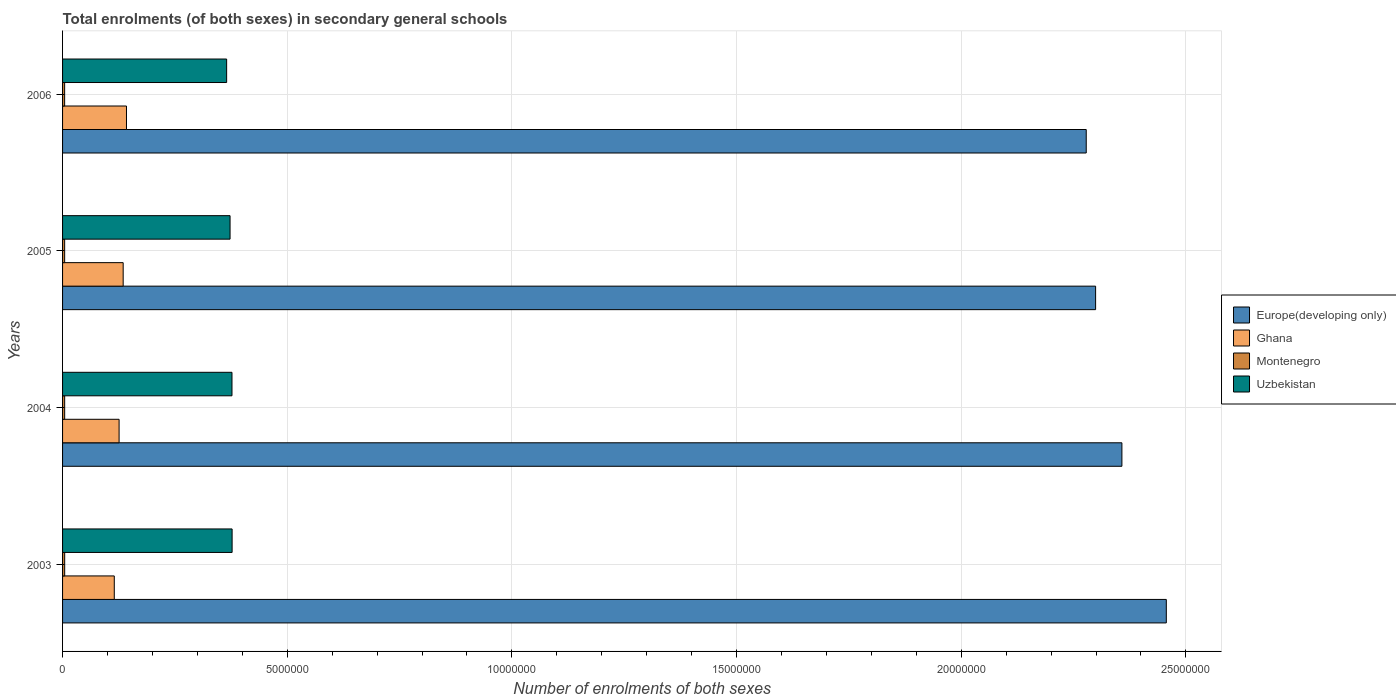How many different coloured bars are there?
Your response must be concise. 4. How many groups of bars are there?
Offer a terse response. 4. Are the number of bars per tick equal to the number of legend labels?
Your answer should be very brief. Yes. Are the number of bars on each tick of the Y-axis equal?
Make the answer very short. Yes. How many bars are there on the 2nd tick from the top?
Offer a terse response. 4. What is the number of enrolments in secondary schools in Uzbekistan in 2005?
Make the answer very short. 3.73e+06. Across all years, what is the maximum number of enrolments in secondary schools in Europe(developing only)?
Your answer should be very brief. 2.46e+07. Across all years, what is the minimum number of enrolments in secondary schools in Uzbekistan?
Your answer should be compact. 3.65e+06. In which year was the number of enrolments in secondary schools in Montenegro maximum?
Provide a short and direct response. 2003. In which year was the number of enrolments in secondary schools in Europe(developing only) minimum?
Offer a very short reply. 2006. What is the total number of enrolments in secondary schools in Uzbekistan in the graph?
Your answer should be very brief. 1.49e+07. What is the difference between the number of enrolments in secondary schools in Ghana in 2004 and that in 2005?
Provide a succinct answer. -9.08e+04. What is the difference between the number of enrolments in secondary schools in Ghana in 2004 and the number of enrolments in secondary schools in Europe(developing only) in 2003?
Provide a succinct answer. -2.33e+07. What is the average number of enrolments in secondary schools in Europe(developing only) per year?
Ensure brevity in your answer.  2.35e+07. In the year 2005, what is the difference between the number of enrolments in secondary schools in Ghana and number of enrolments in secondary schools in Montenegro?
Offer a terse response. 1.30e+06. In how many years, is the number of enrolments in secondary schools in Montenegro greater than 13000000 ?
Ensure brevity in your answer.  0. What is the ratio of the number of enrolments in secondary schools in Montenegro in 2004 to that in 2005?
Your answer should be compact. 1.01. Is the number of enrolments in secondary schools in Ghana in 2003 less than that in 2004?
Your response must be concise. Yes. Is the difference between the number of enrolments in secondary schools in Ghana in 2003 and 2006 greater than the difference between the number of enrolments in secondary schools in Montenegro in 2003 and 2006?
Make the answer very short. No. What is the difference between the highest and the second highest number of enrolments in secondary schools in Ghana?
Your response must be concise. 7.38e+04. What is the difference between the highest and the lowest number of enrolments in secondary schools in Uzbekistan?
Give a very brief answer. 1.22e+05. In how many years, is the number of enrolments in secondary schools in Montenegro greater than the average number of enrolments in secondary schools in Montenegro taken over all years?
Offer a very short reply. 2. Is the sum of the number of enrolments in secondary schools in Europe(developing only) in 2003 and 2004 greater than the maximum number of enrolments in secondary schools in Uzbekistan across all years?
Provide a succinct answer. Yes. Is it the case that in every year, the sum of the number of enrolments in secondary schools in Europe(developing only) and number of enrolments in secondary schools in Ghana is greater than the sum of number of enrolments in secondary schools in Montenegro and number of enrolments in secondary schools in Uzbekistan?
Your answer should be very brief. Yes. What does the 2nd bar from the top in 2004 represents?
Your answer should be compact. Montenegro. What does the 1st bar from the bottom in 2003 represents?
Make the answer very short. Europe(developing only). Is it the case that in every year, the sum of the number of enrolments in secondary schools in Montenegro and number of enrolments in secondary schools in Uzbekistan is greater than the number of enrolments in secondary schools in Europe(developing only)?
Offer a very short reply. No. How many bars are there?
Your answer should be compact. 16. What is the difference between two consecutive major ticks on the X-axis?
Provide a short and direct response. 5.00e+06. Are the values on the major ticks of X-axis written in scientific E-notation?
Your response must be concise. No. How are the legend labels stacked?
Ensure brevity in your answer.  Vertical. What is the title of the graph?
Make the answer very short. Total enrolments (of both sexes) in secondary general schools. What is the label or title of the X-axis?
Keep it short and to the point. Number of enrolments of both sexes. What is the label or title of the Y-axis?
Your response must be concise. Years. What is the Number of enrolments of both sexes in Europe(developing only) in 2003?
Your answer should be compact. 2.46e+07. What is the Number of enrolments of both sexes of Ghana in 2003?
Your answer should be very brief. 1.15e+06. What is the Number of enrolments of both sexes in Montenegro in 2003?
Offer a very short reply. 4.72e+04. What is the Number of enrolments of both sexes of Uzbekistan in 2003?
Your answer should be compact. 3.77e+06. What is the Number of enrolments of both sexes of Europe(developing only) in 2004?
Provide a succinct answer. 2.36e+07. What is the Number of enrolments of both sexes in Ghana in 2004?
Your answer should be very brief. 1.26e+06. What is the Number of enrolments of both sexes in Montenegro in 2004?
Your response must be concise. 4.69e+04. What is the Number of enrolments of both sexes in Uzbekistan in 2004?
Offer a terse response. 3.77e+06. What is the Number of enrolments of both sexes in Europe(developing only) in 2005?
Offer a very short reply. 2.30e+07. What is the Number of enrolments of both sexes in Ghana in 2005?
Your response must be concise. 1.35e+06. What is the Number of enrolments of both sexes of Montenegro in 2005?
Keep it short and to the point. 4.65e+04. What is the Number of enrolments of both sexes in Uzbekistan in 2005?
Keep it short and to the point. 3.73e+06. What is the Number of enrolments of both sexes in Europe(developing only) in 2006?
Provide a succinct answer. 2.28e+07. What is the Number of enrolments of both sexes of Ghana in 2006?
Ensure brevity in your answer.  1.42e+06. What is the Number of enrolments of both sexes in Montenegro in 2006?
Your answer should be very brief. 4.62e+04. What is the Number of enrolments of both sexes in Uzbekistan in 2006?
Keep it short and to the point. 3.65e+06. Across all years, what is the maximum Number of enrolments of both sexes of Europe(developing only)?
Your response must be concise. 2.46e+07. Across all years, what is the maximum Number of enrolments of both sexes in Ghana?
Offer a terse response. 1.42e+06. Across all years, what is the maximum Number of enrolments of both sexes in Montenegro?
Offer a very short reply. 4.72e+04. Across all years, what is the maximum Number of enrolments of both sexes in Uzbekistan?
Give a very brief answer. 3.77e+06. Across all years, what is the minimum Number of enrolments of both sexes of Europe(developing only)?
Your response must be concise. 2.28e+07. Across all years, what is the minimum Number of enrolments of both sexes of Ghana?
Give a very brief answer. 1.15e+06. Across all years, what is the minimum Number of enrolments of both sexes in Montenegro?
Offer a terse response. 4.62e+04. Across all years, what is the minimum Number of enrolments of both sexes in Uzbekistan?
Make the answer very short. 3.65e+06. What is the total Number of enrolments of both sexes of Europe(developing only) in the graph?
Your response must be concise. 9.39e+07. What is the total Number of enrolments of both sexes of Ghana in the graph?
Give a very brief answer. 5.18e+06. What is the total Number of enrolments of both sexes of Montenegro in the graph?
Your response must be concise. 1.87e+05. What is the total Number of enrolments of both sexes of Uzbekistan in the graph?
Give a very brief answer. 1.49e+07. What is the difference between the Number of enrolments of both sexes in Europe(developing only) in 2003 and that in 2004?
Ensure brevity in your answer.  9.88e+05. What is the difference between the Number of enrolments of both sexes of Ghana in 2003 and that in 2004?
Make the answer very short. -1.07e+05. What is the difference between the Number of enrolments of both sexes of Montenegro in 2003 and that in 2004?
Provide a succinct answer. 286. What is the difference between the Number of enrolments of both sexes of Uzbekistan in 2003 and that in 2004?
Your answer should be very brief. 2988. What is the difference between the Number of enrolments of both sexes of Europe(developing only) in 2003 and that in 2005?
Provide a short and direct response. 1.57e+06. What is the difference between the Number of enrolments of both sexes of Ghana in 2003 and that in 2005?
Your answer should be compact. -1.98e+05. What is the difference between the Number of enrolments of both sexes of Montenegro in 2003 and that in 2005?
Your response must be concise. 675. What is the difference between the Number of enrolments of both sexes in Uzbekistan in 2003 and that in 2005?
Your response must be concise. 4.56e+04. What is the difference between the Number of enrolments of both sexes in Europe(developing only) in 2003 and that in 2006?
Ensure brevity in your answer.  1.78e+06. What is the difference between the Number of enrolments of both sexes of Ghana in 2003 and that in 2006?
Keep it short and to the point. -2.72e+05. What is the difference between the Number of enrolments of both sexes of Montenegro in 2003 and that in 2006?
Your answer should be very brief. 968. What is the difference between the Number of enrolments of both sexes in Uzbekistan in 2003 and that in 2006?
Provide a succinct answer. 1.22e+05. What is the difference between the Number of enrolments of both sexes of Europe(developing only) in 2004 and that in 2005?
Offer a terse response. 5.85e+05. What is the difference between the Number of enrolments of both sexes of Ghana in 2004 and that in 2005?
Provide a short and direct response. -9.08e+04. What is the difference between the Number of enrolments of both sexes in Montenegro in 2004 and that in 2005?
Ensure brevity in your answer.  389. What is the difference between the Number of enrolments of both sexes of Uzbekistan in 2004 and that in 2005?
Offer a very short reply. 4.26e+04. What is the difference between the Number of enrolments of both sexes in Europe(developing only) in 2004 and that in 2006?
Provide a short and direct response. 7.94e+05. What is the difference between the Number of enrolments of both sexes in Ghana in 2004 and that in 2006?
Provide a short and direct response. -1.65e+05. What is the difference between the Number of enrolments of both sexes of Montenegro in 2004 and that in 2006?
Provide a short and direct response. 682. What is the difference between the Number of enrolments of both sexes of Uzbekistan in 2004 and that in 2006?
Your response must be concise. 1.19e+05. What is the difference between the Number of enrolments of both sexes of Europe(developing only) in 2005 and that in 2006?
Your response must be concise. 2.09e+05. What is the difference between the Number of enrolments of both sexes in Ghana in 2005 and that in 2006?
Provide a short and direct response. -7.38e+04. What is the difference between the Number of enrolments of both sexes of Montenegro in 2005 and that in 2006?
Offer a very short reply. 293. What is the difference between the Number of enrolments of both sexes in Uzbekistan in 2005 and that in 2006?
Offer a very short reply. 7.63e+04. What is the difference between the Number of enrolments of both sexes of Europe(developing only) in 2003 and the Number of enrolments of both sexes of Ghana in 2004?
Offer a terse response. 2.33e+07. What is the difference between the Number of enrolments of both sexes in Europe(developing only) in 2003 and the Number of enrolments of both sexes in Montenegro in 2004?
Your answer should be compact. 2.45e+07. What is the difference between the Number of enrolments of both sexes in Europe(developing only) in 2003 and the Number of enrolments of both sexes in Uzbekistan in 2004?
Provide a succinct answer. 2.08e+07. What is the difference between the Number of enrolments of both sexes in Ghana in 2003 and the Number of enrolments of both sexes in Montenegro in 2004?
Provide a short and direct response. 1.10e+06. What is the difference between the Number of enrolments of both sexes of Ghana in 2003 and the Number of enrolments of both sexes of Uzbekistan in 2004?
Your answer should be very brief. -2.62e+06. What is the difference between the Number of enrolments of both sexes of Montenegro in 2003 and the Number of enrolments of both sexes of Uzbekistan in 2004?
Provide a short and direct response. -3.72e+06. What is the difference between the Number of enrolments of both sexes of Europe(developing only) in 2003 and the Number of enrolments of both sexes of Ghana in 2005?
Ensure brevity in your answer.  2.32e+07. What is the difference between the Number of enrolments of both sexes in Europe(developing only) in 2003 and the Number of enrolments of both sexes in Montenegro in 2005?
Your answer should be compact. 2.45e+07. What is the difference between the Number of enrolments of both sexes of Europe(developing only) in 2003 and the Number of enrolments of both sexes of Uzbekistan in 2005?
Keep it short and to the point. 2.08e+07. What is the difference between the Number of enrolments of both sexes of Ghana in 2003 and the Number of enrolments of both sexes of Montenegro in 2005?
Provide a short and direct response. 1.10e+06. What is the difference between the Number of enrolments of both sexes in Ghana in 2003 and the Number of enrolments of both sexes in Uzbekistan in 2005?
Offer a terse response. -2.58e+06. What is the difference between the Number of enrolments of both sexes of Montenegro in 2003 and the Number of enrolments of both sexes of Uzbekistan in 2005?
Your answer should be compact. -3.68e+06. What is the difference between the Number of enrolments of both sexes of Europe(developing only) in 2003 and the Number of enrolments of both sexes of Ghana in 2006?
Offer a terse response. 2.31e+07. What is the difference between the Number of enrolments of both sexes in Europe(developing only) in 2003 and the Number of enrolments of both sexes in Montenegro in 2006?
Ensure brevity in your answer.  2.45e+07. What is the difference between the Number of enrolments of both sexes of Europe(developing only) in 2003 and the Number of enrolments of both sexes of Uzbekistan in 2006?
Ensure brevity in your answer.  2.09e+07. What is the difference between the Number of enrolments of both sexes of Ghana in 2003 and the Number of enrolments of both sexes of Montenegro in 2006?
Provide a short and direct response. 1.10e+06. What is the difference between the Number of enrolments of both sexes of Ghana in 2003 and the Number of enrolments of both sexes of Uzbekistan in 2006?
Ensure brevity in your answer.  -2.50e+06. What is the difference between the Number of enrolments of both sexes of Montenegro in 2003 and the Number of enrolments of both sexes of Uzbekistan in 2006?
Keep it short and to the point. -3.60e+06. What is the difference between the Number of enrolments of both sexes in Europe(developing only) in 2004 and the Number of enrolments of both sexes in Ghana in 2005?
Offer a very short reply. 2.22e+07. What is the difference between the Number of enrolments of both sexes of Europe(developing only) in 2004 and the Number of enrolments of both sexes of Montenegro in 2005?
Ensure brevity in your answer.  2.35e+07. What is the difference between the Number of enrolments of both sexes of Europe(developing only) in 2004 and the Number of enrolments of both sexes of Uzbekistan in 2005?
Provide a succinct answer. 1.98e+07. What is the difference between the Number of enrolments of both sexes of Ghana in 2004 and the Number of enrolments of both sexes of Montenegro in 2005?
Ensure brevity in your answer.  1.21e+06. What is the difference between the Number of enrolments of both sexes in Ghana in 2004 and the Number of enrolments of both sexes in Uzbekistan in 2005?
Your answer should be very brief. -2.47e+06. What is the difference between the Number of enrolments of both sexes of Montenegro in 2004 and the Number of enrolments of both sexes of Uzbekistan in 2005?
Your answer should be very brief. -3.68e+06. What is the difference between the Number of enrolments of both sexes in Europe(developing only) in 2004 and the Number of enrolments of both sexes in Ghana in 2006?
Your response must be concise. 2.22e+07. What is the difference between the Number of enrolments of both sexes of Europe(developing only) in 2004 and the Number of enrolments of both sexes of Montenegro in 2006?
Keep it short and to the point. 2.35e+07. What is the difference between the Number of enrolments of both sexes in Europe(developing only) in 2004 and the Number of enrolments of both sexes in Uzbekistan in 2006?
Offer a terse response. 1.99e+07. What is the difference between the Number of enrolments of both sexes of Ghana in 2004 and the Number of enrolments of both sexes of Montenegro in 2006?
Offer a terse response. 1.21e+06. What is the difference between the Number of enrolments of both sexes in Ghana in 2004 and the Number of enrolments of both sexes in Uzbekistan in 2006?
Your answer should be compact. -2.39e+06. What is the difference between the Number of enrolments of both sexes in Montenegro in 2004 and the Number of enrolments of both sexes in Uzbekistan in 2006?
Give a very brief answer. -3.60e+06. What is the difference between the Number of enrolments of both sexes of Europe(developing only) in 2005 and the Number of enrolments of both sexes of Ghana in 2006?
Your answer should be very brief. 2.16e+07. What is the difference between the Number of enrolments of both sexes in Europe(developing only) in 2005 and the Number of enrolments of both sexes in Montenegro in 2006?
Your answer should be compact. 2.29e+07. What is the difference between the Number of enrolments of both sexes in Europe(developing only) in 2005 and the Number of enrolments of both sexes in Uzbekistan in 2006?
Keep it short and to the point. 1.93e+07. What is the difference between the Number of enrolments of both sexes of Ghana in 2005 and the Number of enrolments of both sexes of Montenegro in 2006?
Your response must be concise. 1.30e+06. What is the difference between the Number of enrolments of both sexes in Ghana in 2005 and the Number of enrolments of both sexes in Uzbekistan in 2006?
Offer a terse response. -2.30e+06. What is the difference between the Number of enrolments of both sexes in Montenegro in 2005 and the Number of enrolments of both sexes in Uzbekistan in 2006?
Give a very brief answer. -3.61e+06. What is the average Number of enrolments of both sexes in Europe(developing only) per year?
Your answer should be very brief. 2.35e+07. What is the average Number of enrolments of both sexes of Ghana per year?
Your answer should be very brief. 1.30e+06. What is the average Number of enrolments of both sexes in Montenegro per year?
Keep it short and to the point. 4.67e+04. What is the average Number of enrolments of both sexes of Uzbekistan per year?
Provide a succinct answer. 3.73e+06. In the year 2003, what is the difference between the Number of enrolments of both sexes in Europe(developing only) and Number of enrolments of both sexes in Ghana?
Your response must be concise. 2.34e+07. In the year 2003, what is the difference between the Number of enrolments of both sexes in Europe(developing only) and Number of enrolments of both sexes in Montenegro?
Offer a terse response. 2.45e+07. In the year 2003, what is the difference between the Number of enrolments of both sexes in Europe(developing only) and Number of enrolments of both sexes in Uzbekistan?
Make the answer very short. 2.08e+07. In the year 2003, what is the difference between the Number of enrolments of both sexes of Ghana and Number of enrolments of both sexes of Montenegro?
Your answer should be very brief. 1.10e+06. In the year 2003, what is the difference between the Number of enrolments of both sexes of Ghana and Number of enrolments of both sexes of Uzbekistan?
Ensure brevity in your answer.  -2.62e+06. In the year 2003, what is the difference between the Number of enrolments of both sexes of Montenegro and Number of enrolments of both sexes of Uzbekistan?
Provide a short and direct response. -3.73e+06. In the year 2004, what is the difference between the Number of enrolments of both sexes in Europe(developing only) and Number of enrolments of both sexes in Ghana?
Provide a short and direct response. 2.23e+07. In the year 2004, what is the difference between the Number of enrolments of both sexes in Europe(developing only) and Number of enrolments of both sexes in Montenegro?
Your response must be concise. 2.35e+07. In the year 2004, what is the difference between the Number of enrolments of both sexes of Europe(developing only) and Number of enrolments of both sexes of Uzbekistan?
Provide a succinct answer. 1.98e+07. In the year 2004, what is the difference between the Number of enrolments of both sexes in Ghana and Number of enrolments of both sexes in Montenegro?
Provide a succinct answer. 1.21e+06. In the year 2004, what is the difference between the Number of enrolments of both sexes in Ghana and Number of enrolments of both sexes in Uzbekistan?
Provide a succinct answer. -2.51e+06. In the year 2004, what is the difference between the Number of enrolments of both sexes of Montenegro and Number of enrolments of both sexes of Uzbekistan?
Ensure brevity in your answer.  -3.72e+06. In the year 2005, what is the difference between the Number of enrolments of both sexes in Europe(developing only) and Number of enrolments of both sexes in Ghana?
Give a very brief answer. 2.16e+07. In the year 2005, what is the difference between the Number of enrolments of both sexes in Europe(developing only) and Number of enrolments of both sexes in Montenegro?
Give a very brief answer. 2.29e+07. In the year 2005, what is the difference between the Number of enrolments of both sexes in Europe(developing only) and Number of enrolments of both sexes in Uzbekistan?
Make the answer very short. 1.93e+07. In the year 2005, what is the difference between the Number of enrolments of both sexes in Ghana and Number of enrolments of both sexes in Montenegro?
Give a very brief answer. 1.30e+06. In the year 2005, what is the difference between the Number of enrolments of both sexes of Ghana and Number of enrolments of both sexes of Uzbekistan?
Your answer should be compact. -2.38e+06. In the year 2005, what is the difference between the Number of enrolments of both sexes in Montenegro and Number of enrolments of both sexes in Uzbekistan?
Provide a succinct answer. -3.68e+06. In the year 2006, what is the difference between the Number of enrolments of both sexes in Europe(developing only) and Number of enrolments of both sexes in Ghana?
Make the answer very short. 2.14e+07. In the year 2006, what is the difference between the Number of enrolments of both sexes in Europe(developing only) and Number of enrolments of both sexes in Montenegro?
Offer a terse response. 2.27e+07. In the year 2006, what is the difference between the Number of enrolments of both sexes of Europe(developing only) and Number of enrolments of both sexes of Uzbekistan?
Provide a short and direct response. 1.91e+07. In the year 2006, what is the difference between the Number of enrolments of both sexes in Ghana and Number of enrolments of both sexes in Montenegro?
Give a very brief answer. 1.38e+06. In the year 2006, what is the difference between the Number of enrolments of both sexes in Ghana and Number of enrolments of both sexes in Uzbekistan?
Keep it short and to the point. -2.23e+06. In the year 2006, what is the difference between the Number of enrolments of both sexes in Montenegro and Number of enrolments of both sexes in Uzbekistan?
Make the answer very short. -3.61e+06. What is the ratio of the Number of enrolments of both sexes in Europe(developing only) in 2003 to that in 2004?
Your answer should be very brief. 1.04. What is the ratio of the Number of enrolments of both sexes of Ghana in 2003 to that in 2004?
Ensure brevity in your answer.  0.91. What is the ratio of the Number of enrolments of both sexes in Uzbekistan in 2003 to that in 2004?
Your answer should be very brief. 1. What is the ratio of the Number of enrolments of both sexes in Europe(developing only) in 2003 to that in 2005?
Your answer should be compact. 1.07. What is the ratio of the Number of enrolments of both sexes in Ghana in 2003 to that in 2005?
Offer a very short reply. 0.85. What is the ratio of the Number of enrolments of both sexes in Montenegro in 2003 to that in 2005?
Give a very brief answer. 1.01. What is the ratio of the Number of enrolments of both sexes in Uzbekistan in 2003 to that in 2005?
Keep it short and to the point. 1.01. What is the ratio of the Number of enrolments of both sexes of Europe(developing only) in 2003 to that in 2006?
Offer a terse response. 1.08. What is the ratio of the Number of enrolments of both sexes in Ghana in 2003 to that in 2006?
Your answer should be compact. 0.81. What is the ratio of the Number of enrolments of both sexes of Montenegro in 2003 to that in 2006?
Offer a terse response. 1.02. What is the ratio of the Number of enrolments of both sexes in Uzbekistan in 2003 to that in 2006?
Your answer should be compact. 1.03. What is the ratio of the Number of enrolments of both sexes in Europe(developing only) in 2004 to that in 2005?
Provide a succinct answer. 1.03. What is the ratio of the Number of enrolments of both sexes in Ghana in 2004 to that in 2005?
Ensure brevity in your answer.  0.93. What is the ratio of the Number of enrolments of both sexes in Montenegro in 2004 to that in 2005?
Your response must be concise. 1.01. What is the ratio of the Number of enrolments of both sexes of Uzbekistan in 2004 to that in 2005?
Your answer should be very brief. 1.01. What is the ratio of the Number of enrolments of both sexes of Europe(developing only) in 2004 to that in 2006?
Offer a terse response. 1.03. What is the ratio of the Number of enrolments of both sexes of Ghana in 2004 to that in 2006?
Provide a short and direct response. 0.88. What is the ratio of the Number of enrolments of both sexes in Montenegro in 2004 to that in 2006?
Provide a succinct answer. 1.01. What is the ratio of the Number of enrolments of both sexes in Uzbekistan in 2004 to that in 2006?
Offer a very short reply. 1.03. What is the ratio of the Number of enrolments of both sexes in Europe(developing only) in 2005 to that in 2006?
Your response must be concise. 1.01. What is the ratio of the Number of enrolments of both sexes of Ghana in 2005 to that in 2006?
Give a very brief answer. 0.95. What is the ratio of the Number of enrolments of both sexes of Montenegro in 2005 to that in 2006?
Your response must be concise. 1.01. What is the ratio of the Number of enrolments of both sexes of Uzbekistan in 2005 to that in 2006?
Offer a terse response. 1.02. What is the difference between the highest and the second highest Number of enrolments of both sexes of Europe(developing only)?
Your answer should be very brief. 9.88e+05. What is the difference between the highest and the second highest Number of enrolments of both sexes of Ghana?
Ensure brevity in your answer.  7.38e+04. What is the difference between the highest and the second highest Number of enrolments of both sexes in Montenegro?
Your answer should be compact. 286. What is the difference between the highest and the second highest Number of enrolments of both sexes of Uzbekistan?
Ensure brevity in your answer.  2988. What is the difference between the highest and the lowest Number of enrolments of both sexes in Europe(developing only)?
Provide a succinct answer. 1.78e+06. What is the difference between the highest and the lowest Number of enrolments of both sexes of Ghana?
Offer a very short reply. 2.72e+05. What is the difference between the highest and the lowest Number of enrolments of both sexes of Montenegro?
Provide a short and direct response. 968. What is the difference between the highest and the lowest Number of enrolments of both sexes of Uzbekistan?
Provide a succinct answer. 1.22e+05. 